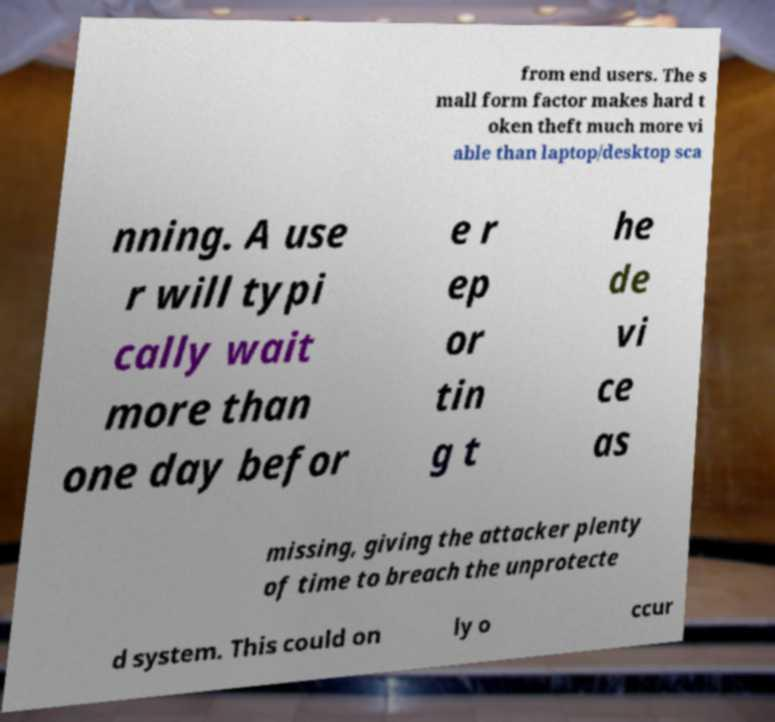Can you accurately transcribe the text from the provided image for me? from end users. The s mall form factor makes hard t oken theft much more vi able than laptop/desktop sca nning. A use r will typi cally wait more than one day befor e r ep or tin g t he de vi ce as missing, giving the attacker plenty of time to breach the unprotecte d system. This could on ly o ccur 